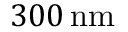<formula> <loc_0><loc_0><loc_500><loc_500>{ 3 0 0 } \, n m</formula> 